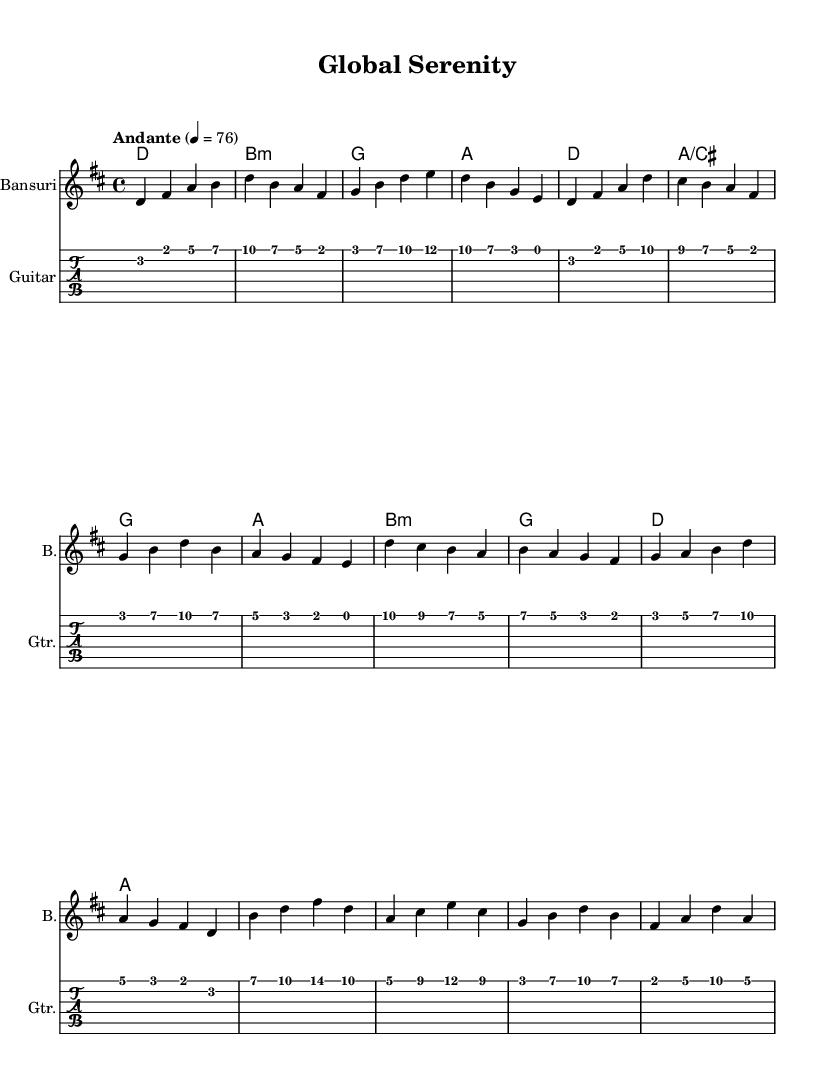What is the key signature of this music? The key signature is D major, which has two sharps (F# and C#). This can be identified by looking at the key signature at the beginning of the staff where the sharps are indicated.
Answer: D major What is the time signature of this piece? The time signature is 4/4, which means there are four beats in each measure and the quarter note gets one beat. This can be seen at the beginning of the score next to the key signature.
Answer: 4/4 What is the tempo marking for this music? The tempo marking is "Andante" which indicates a moderate pace, typically a walking speed. This is specified at the beginning of the score.
Answer: Andante How many measures are in the full score? There are 12 measures in total across the sections (intro, verse, chorus, bridge). By counting each measure in the score, we can determine the total.
Answer: 12 What instrument is indicated for the melody? The instrument indicated for the melody is the Bansuri, a traditional bamboo flute from India. This is noted at the beginning of the staff.
Answer: Bansuri Which chord appears at the beginning of the harmony section? The chord that appears at the beginning of the harmony section is D major. This is the first chord listed in the chord mode, denoting the harmonic foundation.
Answer: D What type of music does this score represent? This score represents Fusion music, combining elements from various world music traditions to create a calming melody. This is indicated in the title and style of the compositions.
Answer: Fusion 